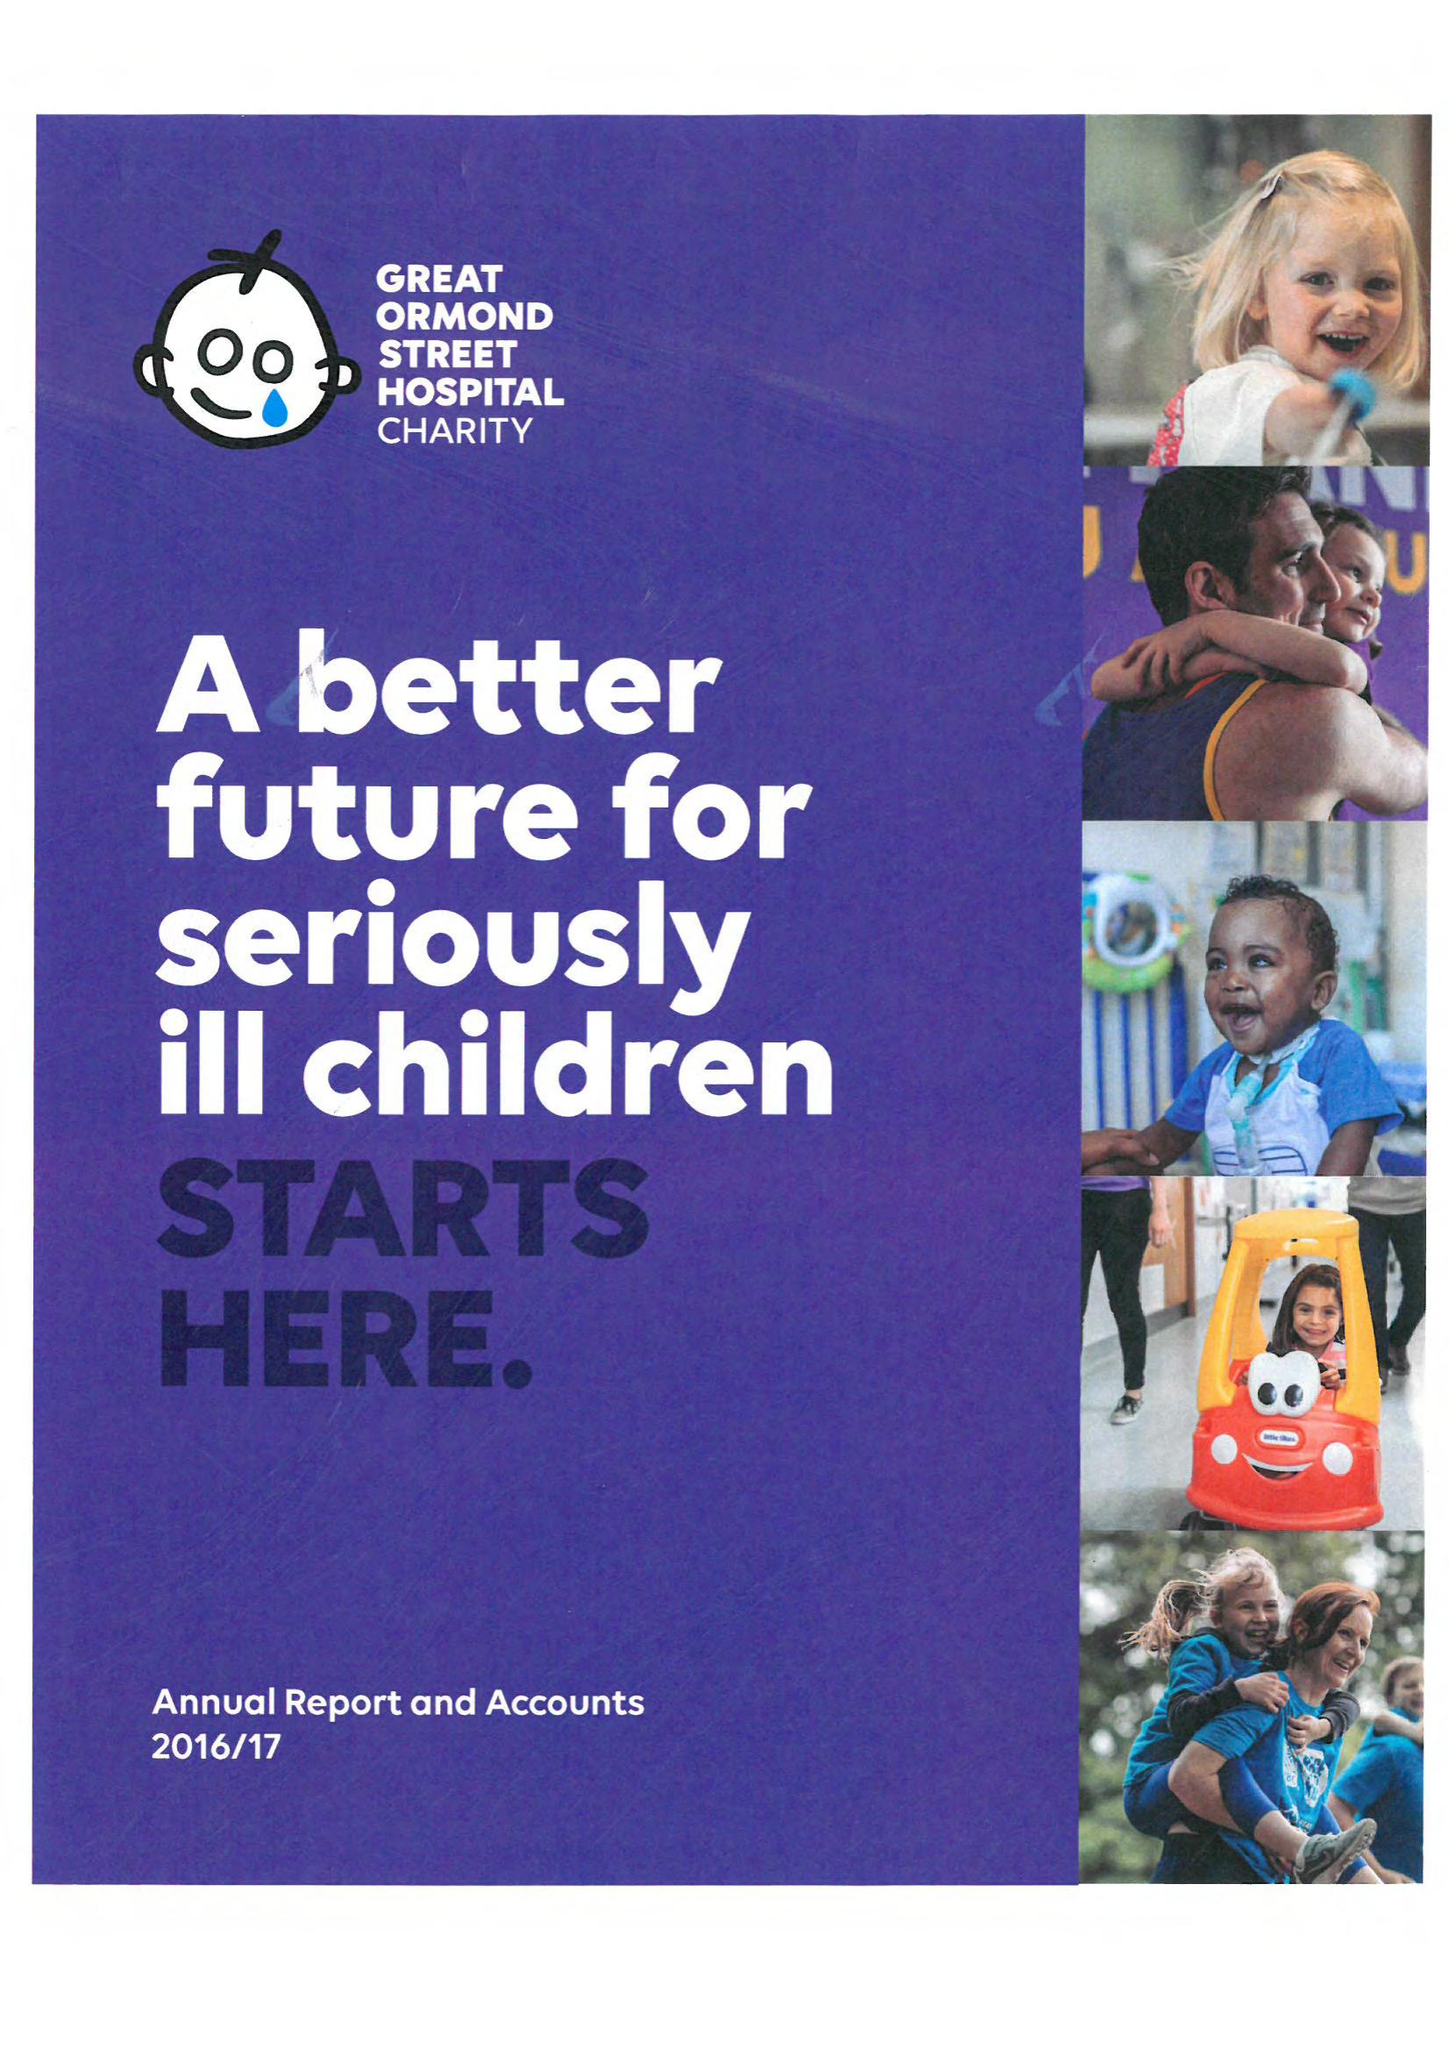What is the value for the address__street_line?
Answer the question using a single word or phrase. 40 BERNARD STREET 